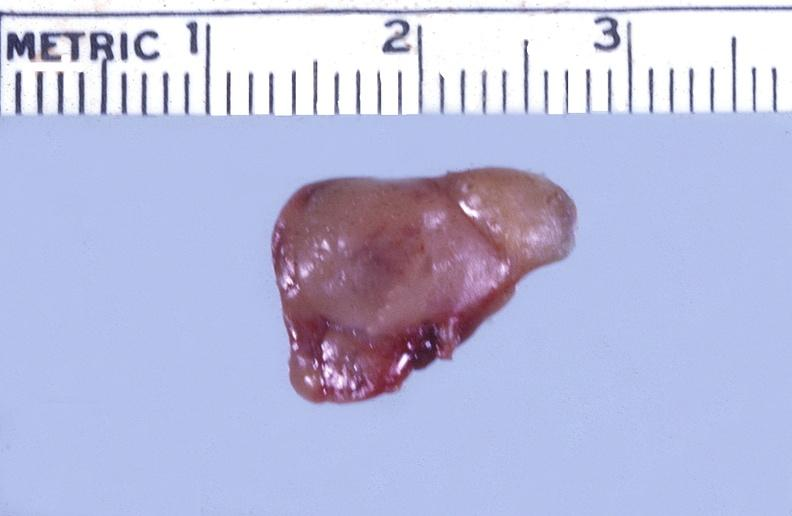s endocrine present?
Answer the question using a single word or phrase. Yes 